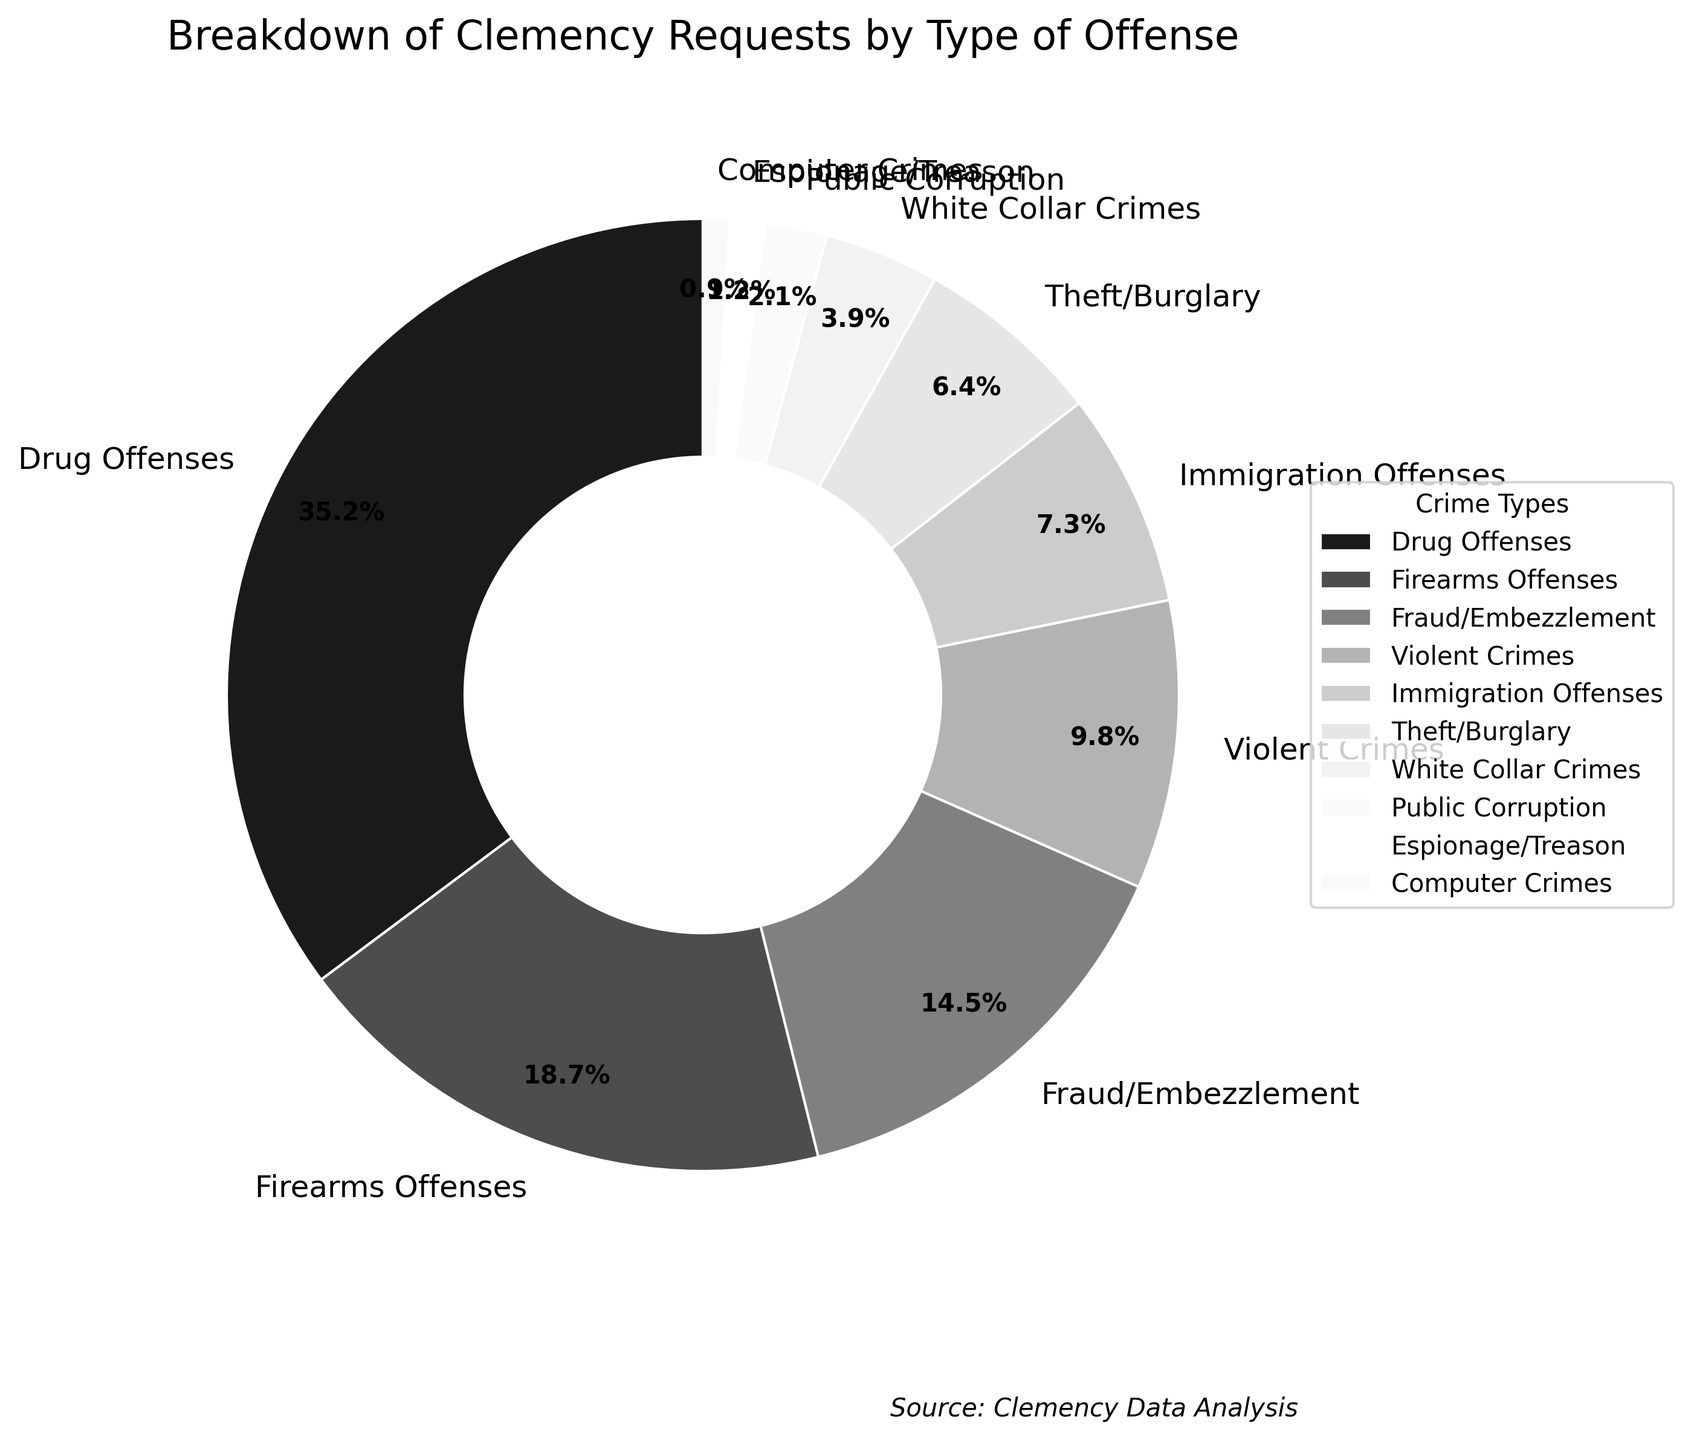Which crime type has the highest percentage of clemency requests? First, look at the pie chart and identify the segment with the largest slice. The legend or labels will help in recognizing the crime type associated with this segment.
Answer: Drug Offenses Which crime type has the lowest percentage of clemency requests? Identify the smallest slice in the pie chart and refer to the legend or labels to find the corresponding crime type.
Answer: Computer Crimes How much higher is the percentage of clemency requests for drug offenses compared to firearms offenses? Locate the percentages for Drug Offenses (35.2%) and Firearms Offenses (18.7%) in the chart. Subtract the smaller value from the larger one: 35.2 - 18.7.
Answer: 16.5% What is the combined percentage of clemency requests for fraud/embezzlement and violent crimes? Find the percentages for Fraud/Embezzlement (14.5%) and Violent Crimes (9.8%) in the chart. Add these percentages together: 14.5 + 9.8.
Answer: 24.3% What percentage of clemency requests are for offenses other than drug and firearms offenses? Sum up the percentages of clemency requests for all other crime types (excluding Drug Offenses and Firearms Offenses). Subtract the sum of the percentages for Drug Offenses (35.2%) and Firearms Offenses (18.7%) from 100%: 100 - (35.2 + 18.7).
Answer: 46.1% Which crime types have a percentage of clemency requests greater than 10%? Scan the pie chart for segments with labels indicating percentages above 10%.
Answer: Drug Offenses, Firearms Offenses, Fraud/Embezzlement How does the percentage of clemency requests for immigration offenses compare to that for theft/burglary? Find the percentages for Immigration Offenses (7.3%) and Theft/Burglary (6.4%) in the chart. Compare the two values.
Answer: Immigration Offenses > Theft/Burglary What is the total percentage of clemency requests for white collar crimes, public corruption, and espionage/treason combined? Find the percentages for White Collar Crimes (3.9%), Public Corruption (2.1%), and Espionage/Treason (1.2%) in the chart. Add these values together: 3.9 + 2.1 + 1.2.
Answer: 7.2% Which crime types have a percentage of clemency requests less than 5%? Identify the segments associated with crime types having percentages below 5% on the pie chart.
Answer: White Collar Crimes, Public Corruption, Espionage/Treason, Computer Crimes What is the difference in the percentage of clemency requests between violent crimes and computer crimes? Look at the percentages for Violent Crimes (9.8%) and Computer Crimes (0.9%) in the chart. Subtract the smaller value from the larger one: 9.8 - 0.9.
Answer: 8.9% 